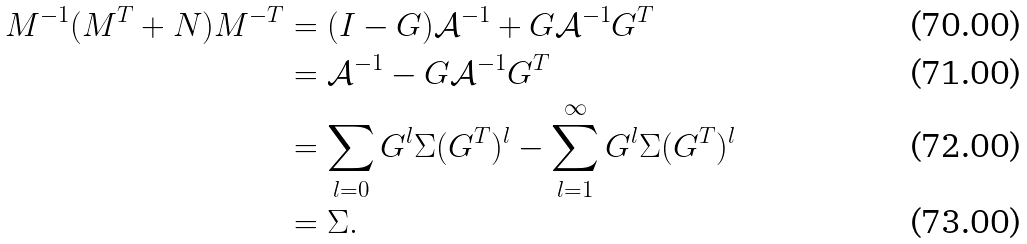<formula> <loc_0><loc_0><loc_500><loc_500>M ^ { - 1 } ( M ^ { T } + N ) M ^ { - T } & = ( I - G ) \mathcal { A } ^ { - 1 } + G \mathcal { A } ^ { - 1 } G ^ { T } \\ & = \mathcal { A } ^ { - 1 } - G \mathcal { A } ^ { - 1 } G ^ { T } \\ & = \sum _ { l = 0 } G ^ { l } \Sigma ( G ^ { T } ) ^ { l } - \sum _ { l = 1 } ^ { \infty } G ^ { l } \Sigma ( G ^ { T } ) ^ { l } \\ & = \Sigma .</formula> 